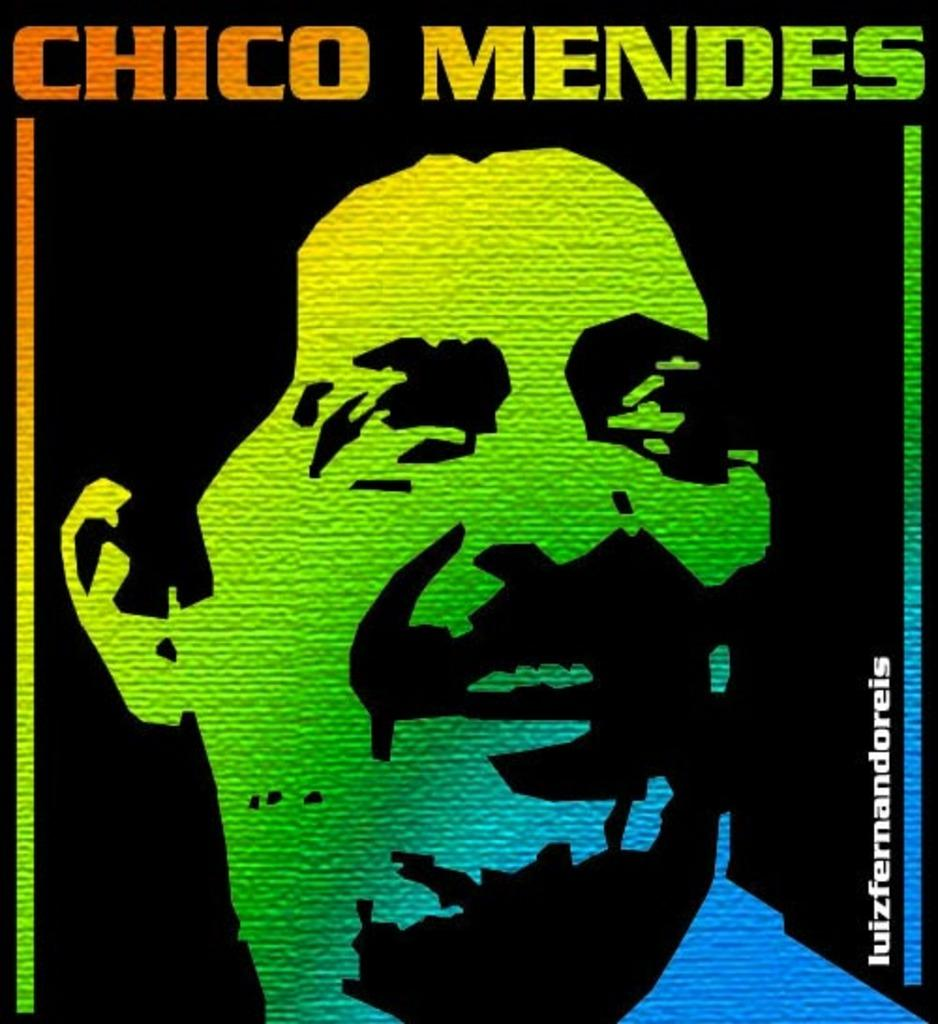<image>
Create a compact narrative representing the image presented. A colorful piece of artwork which features a man and the words Chico Mendes. 